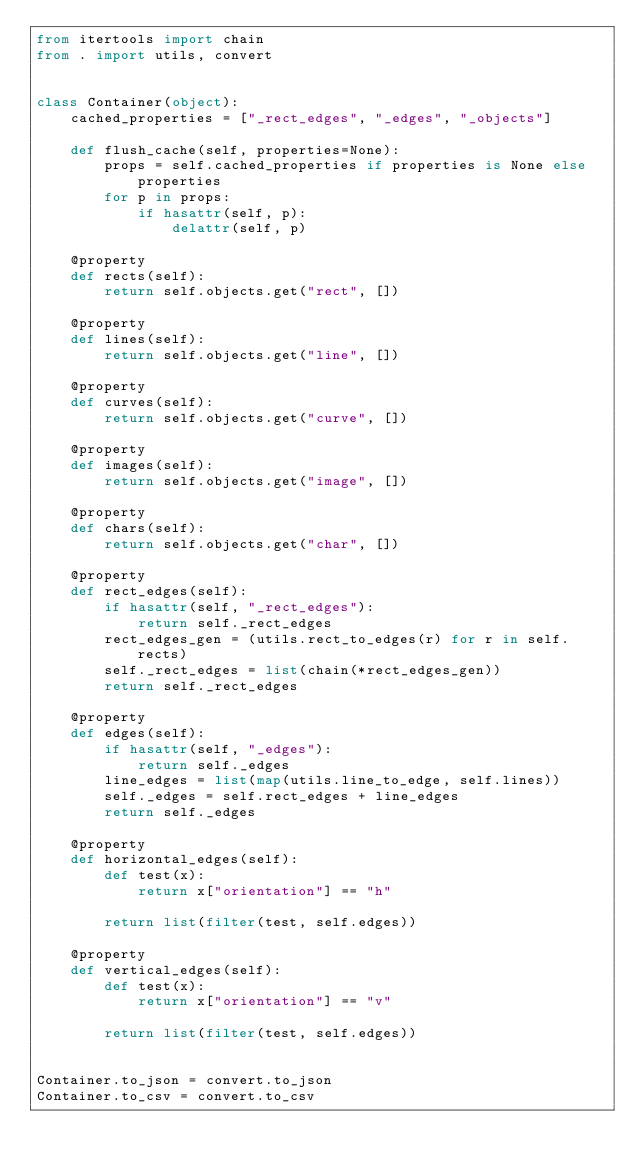<code> <loc_0><loc_0><loc_500><loc_500><_Python_>from itertools import chain
from . import utils, convert


class Container(object):
    cached_properties = ["_rect_edges", "_edges", "_objects"]

    def flush_cache(self, properties=None):
        props = self.cached_properties if properties is None else properties
        for p in props:
            if hasattr(self, p):
                delattr(self, p)

    @property
    def rects(self):
        return self.objects.get("rect", [])

    @property
    def lines(self):
        return self.objects.get("line", [])

    @property
    def curves(self):
        return self.objects.get("curve", [])

    @property
    def images(self):
        return self.objects.get("image", [])

    @property
    def chars(self):
        return self.objects.get("char", [])

    @property
    def rect_edges(self):
        if hasattr(self, "_rect_edges"):
            return self._rect_edges
        rect_edges_gen = (utils.rect_to_edges(r) for r in self.rects)
        self._rect_edges = list(chain(*rect_edges_gen))
        return self._rect_edges

    @property
    def edges(self):
        if hasattr(self, "_edges"):
            return self._edges
        line_edges = list(map(utils.line_to_edge, self.lines))
        self._edges = self.rect_edges + line_edges
        return self._edges

    @property
    def horizontal_edges(self):
        def test(x):
            return x["orientation"] == "h"

        return list(filter(test, self.edges))

    @property
    def vertical_edges(self):
        def test(x):
            return x["orientation"] == "v"

        return list(filter(test, self.edges))


Container.to_json = convert.to_json
Container.to_csv = convert.to_csv
</code> 